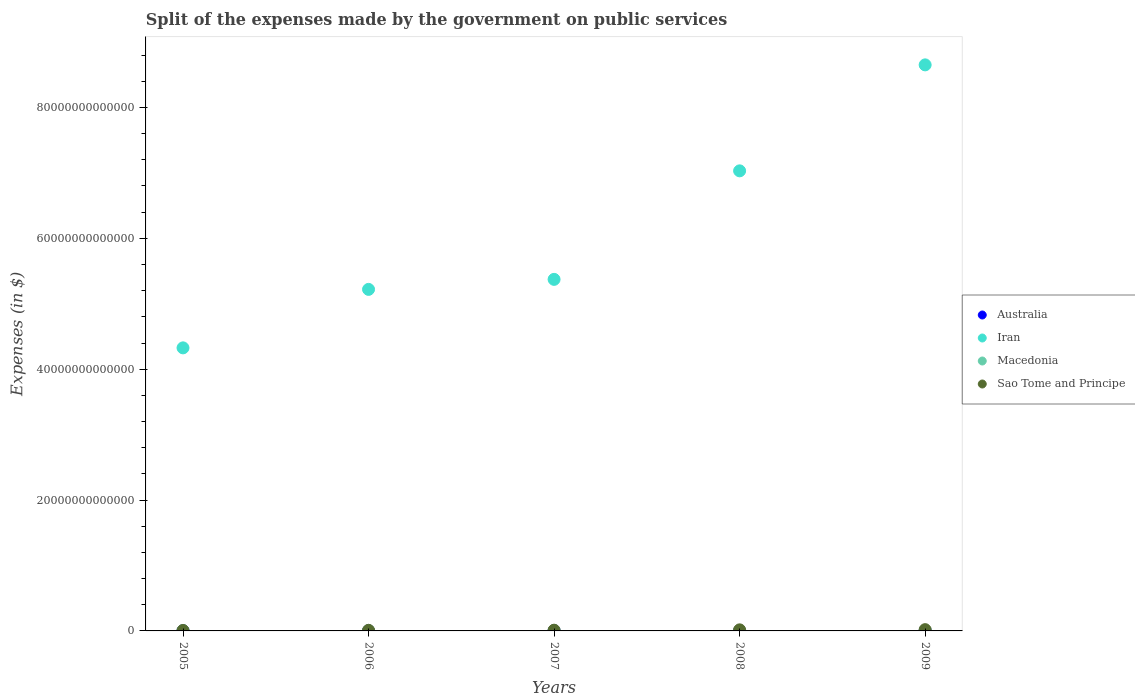What is the expenses made by the government on public services in Macedonia in 2008?
Your answer should be compact. 1.87e+1. Across all years, what is the maximum expenses made by the government on public services in Sao Tome and Principe?
Ensure brevity in your answer.  1.95e+11. Across all years, what is the minimum expenses made by the government on public services in Iran?
Keep it short and to the point. 4.33e+13. What is the total expenses made by the government on public services in Iran in the graph?
Provide a short and direct response. 3.06e+14. What is the difference between the expenses made by the government on public services in Australia in 2007 and that in 2008?
Your answer should be compact. -1.55e+09. What is the difference between the expenses made by the government on public services in Macedonia in 2006 and the expenses made by the government on public services in Australia in 2009?
Your answer should be very brief. -6.54e+09. What is the average expenses made by the government on public services in Sao Tome and Principe per year?
Your answer should be very brief. 1.26e+11. In the year 2006, what is the difference between the expenses made by the government on public services in Australia and expenses made by the government on public services in Sao Tome and Principe?
Ensure brevity in your answer.  -6.47e+1. In how many years, is the expenses made by the government on public services in Macedonia greater than 16000000000000 $?
Provide a short and direct response. 0. What is the ratio of the expenses made by the government on public services in Iran in 2007 to that in 2008?
Keep it short and to the point. 0.76. What is the difference between the highest and the second highest expenses made by the government on public services in Australia?
Ensure brevity in your answer.  2.16e+09. What is the difference between the highest and the lowest expenses made by the government on public services in Iran?
Your answer should be very brief. 4.32e+13. In how many years, is the expenses made by the government on public services in Macedonia greater than the average expenses made by the government on public services in Macedonia taken over all years?
Your response must be concise. 3. Does the expenses made by the government on public services in Macedonia monotonically increase over the years?
Your answer should be compact. No. Is the expenses made by the government on public services in Macedonia strictly greater than the expenses made by the government on public services in Australia over the years?
Make the answer very short. No. How many dotlines are there?
Make the answer very short. 4. What is the difference between two consecutive major ticks on the Y-axis?
Provide a short and direct response. 2.00e+13. Are the values on the major ticks of Y-axis written in scientific E-notation?
Keep it short and to the point. No. Does the graph contain any zero values?
Your answer should be compact. No. Where does the legend appear in the graph?
Make the answer very short. Center right. What is the title of the graph?
Your answer should be very brief. Split of the expenses made by the government on public services. What is the label or title of the Y-axis?
Offer a terse response. Expenses (in $). What is the Expenses (in $) in Australia in 2005?
Provide a succinct answer. 2.42e+1. What is the Expenses (in $) in Iran in 2005?
Offer a terse response. 4.33e+13. What is the Expenses (in $) in Macedonia in 2005?
Provide a short and direct response. 2.57e+1. What is the Expenses (in $) in Sao Tome and Principe in 2005?
Keep it short and to the point. 6.62e+1. What is the Expenses (in $) in Australia in 2006?
Your answer should be compact. 2.60e+1. What is the Expenses (in $) in Iran in 2006?
Ensure brevity in your answer.  5.22e+13. What is the Expenses (in $) in Macedonia in 2006?
Keep it short and to the point. 2.65e+1. What is the Expenses (in $) in Sao Tome and Principe in 2006?
Ensure brevity in your answer.  9.07e+1. What is the Expenses (in $) of Australia in 2007?
Give a very brief answer. 2.94e+1. What is the Expenses (in $) in Iran in 2007?
Provide a short and direct response. 5.37e+13. What is the Expenses (in $) of Macedonia in 2007?
Your response must be concise. 2.84e+1. What is the Expenses (in $) of Sao Tome and Principe in 2007?
Make the answer very short. 1.12e+11. What is the Expenses (in $) of Australia in 2008?
Keep it short and to the point. 3.09e+1. What is the Expenses (in $) of Iran in 2008?
Offer a very short reply. 7.03e+13. What is the Expenses (in $) in Macedonia in 2008?
Provide a short and direct response. 1.87e+1. What is the Expenses (in $) in Sao Tome and Principe in 2008?
Your answer should be compact. 1.64e+11. What is the Expenses (in $) of Australia in 2009?
Make the answer very short. 3.31e+1. What is the Expenses (in $) in Iran in 2009?
Offer a terse response. 8.65e+13. What is the Expenses (in $) in Macedonia in 2009?
Your answer should be compact. 1.62e+1. What is the Expenses (in $) of Sao Tome and Principe in 2009?
Provide a short and direct response. 1.95e+11. Across all years, what is the maximum Expenses (in $) in Australia?
Your response must be concise. 3.31e+1. Across all years, what is the maximum Expenses (in $) in Iran?
Your response must be concise. 8.65e+13. Across all years, what is the maximum Expenses (in $) in Macedonia?
Provide a succinct answer. 2.84e+1. Across all years, what is the maximum Expenses (in $) of Sao Tome and Principe?
Give a very brief answer. 1.95e+11. Across all years, what is the minimum Expenses (in $) of Australia?
Offer a very short reply. 2.42e+1. Across all years, what is the minimum Expenses (in $) in Iran?
Ensure brevity in your answer.  4.33e+13. Across all years, what is the minimum Expenses (in $) in Macedonia?
Give a very brief answer. 1.62e+1. Across all years, what is the minimum Expenses (in $) in Sao Tome and Principe?
Ensure brevity in your answer.  6.62e+1. What is the total Expenses (in $) in Australia in the graph?
Your answer should be very brief. 1.44e+11. What is the total Expenses (in $) of Iran in the graph?
Your answer should be very brief. 3.06e+14. What is the total Expenses (in $) in Macedonia in the graph?
Your response must be concise. 1.16e+11. What is the total Expenses (in $) in Sao Tome and Principe in the graph?
Offer a very short reply. 6.28e+11. What is the difference between the Expenses (in $) of Australia in 2005 and that in 2006?
Ensure brevity in your answer.  -1.84e+09. What is the difference between the Expenses (in $) in Iran in 2005 and that in 2006?
Give a very brief answer. -8.94e+12. What is the difference between the Expenses (in $) of Macedonia in 2005 and that in 2006?
Make the answer very short. -8.61e+08. What is the difference between the Expenses (in $) of Sao Tome and Principe in 2005 and that in 2006?
Your answer should be compact. -2.45e+1. What is the difference between the Expenses (in $) in Australia in 2005 and that in 2007?
Provide a short and direct response. -5.17e+09. What is the difference between the Expenses (in $) in Iran in 2005 and that in 2007?
Offer a terse response. -1.05e+13. What is the difference between the Expenses (in $) of Macedonia in 2005 and that in 2007?
Provide a short and direct response. -2.77e+09. What is the difference between the Expenses (in $) of Sao Tome and Principe in 2005 and that in 2007?
Make the answer very short. -4.53e+1. What is the difference between the Expenses (in $) of Australia in 2005 and that in 2008?
Your response must be concise. -6.72e+09. What is the difference between the Expenses (in $) in Iran in 2005 and that in 2008?
Your response must be concise. -2.71e+13. What is the difference between the Expenses (in $) of Macedonia in 2005 and that in 2008?
Provide a short and direct response. 6.93e+09. What is the difference between the Expenses (in $) in Sao Tome and Principe in 2005 and that in 2008?
Give a very brief answer. -9.81e+1. What is the difference between the Expenses (in $) in Australia in 2005 and that in 2009?
Your answer should be very brief. -8.88e+09. What is the difference between the Expenses (in $) of Iran in 2005 and that in 2009?
Your answer should be compact. -4.32e+13. What is the difference between the Expenses (in $) of Macedonia in 2005 and that in 2009?
Make the answer very short. 9.46e+09. What is the difference between the Expenses (in $) in Sao Tome and Principe in 2005 and that in 2009?
Offer a very short reply. -1.29e+11. What is the difference between the Expenses (in $) of Australia in 2006 and that in 2007?
Your answer should be compact. -3.32e+09. What is the difference between the Expenses (in $) in Iran in 2006 and that in 2007?
Keep it short and to the point. -1.53e+12. What is the difference between the Expenses (in $) of Macedonia in 2006 and that in 2007?
Give a very brief answer. -1.91e+09. What is the difference between the Expenses (in $) of Sao Tome and Principe in 2006 and that in 2007?
Your response must be concise. -2.08e+1. What is the difference between the Expenses (in $) in Australia in 2006 and that in 2008?
Make the answer very short. -4.88e+09. What is the difference between the Expenses (in $) of Iran in 2006 and that in 2008?
Give a very brief answer. -1.81e+13. What is the difference between the Expenses (in $) in Macedonia in 2006 and that in 2008?
Your response must be concise. 7.79e+09. What is the difference between the Expenses (in $) of Sao Tome and Principe in 2006 and that in 2008?
Offer a very short reply. -7.36e+1. What is the difference between the Expenses (in $) of Australia in 2006 and that in 2009?
Keep it short and to the point. -7.03e+09. What is the difference between the Expenses (in $) in Iran in 2006 and that in 2009?
Make the answer very short. -3.43e+13. What is the difference between the Expenses (in $) in Macedonia in 2006 and that in 2009?
Provide a succinct answer. 1.03e+1. What is the difference between the Expenses (in $) of Sao Tome and Principe in 2006 and that in 2009?
Provide a succinct answer. -1.04e+11. What is the difference between the Expenses (in $) of Australia in 2007 and that in 2008?
Offer a very short reply. -1.55e+09. What is the difference between the Expenses (in $) of Iran in 2007 and that in 2008?
Provide a short and direct response. -1.66e+13. What is the difference between the Expenses (in $) in Macedonia in 2007 and that in 2008?
Your answer should be compact. 9.70e+09. What is the difference between the Expenses (in $) of Sao Tome and Principe in 2007 and that in 2008?
Your response must be concise. -5.27e+1. What is the difference between the Expenses (in $) in Australia in 2007 and that in 2009?
Keep it short and to the point. -3.71e+09. What is the difference between the Expenses (in $) of Iran in 2007 and that in 2009?
Provide a short and direct response. -3.28e+13. What is the difference between the Expenses (in $) in Macedonia in 2007 and that in 2009?
Your response must be concise. 1.22e+1. What is the difference between the Expenses (in $) of Sao Tome and Principe in 2007 and that in 2009?
Offer a very short reply. -8.33e+1. What is the difference between the Expenses (in $) of Australia in 2008 and that in 2009?
Make the answer very short. -2.16e+09. What is the difference between the Expenses (in $) of Iran in 2008 and that in 2009?
Offer a very short reply. -1.62e+13. What is the difference between the Expenses (in $) in Macedonia in 2008 and that in 2009?
Your response must be concise. 2.52e+09. What is the difference between the Expenses (in $) in Sao Tome and Principe in 2008 and that in 2009?
Provide a succinct answer. -3.06e+1. What is the difference between the Expenses (in $) in Australia in 2005 and the Expenses (in $) in Iran in 2006?
Keep it short and to the point. -5.22e+13. What is the difference between the Expenses (in $) in Australia in 2005 and the Expenses (in $) in Macedonia in 2006?
Your answer should be compact. -2.33e+09. What is the difference between the Expenses (in $) of Australia in 2005 and the Expenses (in $) of Sao Tome and Principe in 2006?
Ensure brevity in your answer.  -6.65e+1. What is the difference between the Expenses (in $) of Iran in 2005 and the Expenses (in $) of Macedonia in 2006?
Provide a succinct answer. 4.32e+13. What is the difference between the Expenses (in $) of Iran in 2005 and the Expenses (in $) of Sao Tome and Principe in 2006?
Ensure brevity in your answer.  4.32e+13. What is the difference between the Expenses (in $) of Macedonia in 2005 and the Expenses (in $) of Sao Tome and Principe in 2006?
Provide a succinct answer. -6.50e+1. What is the difference between the Expenses (in $) in Australia in 2005 and the Expenses (in $) in Iran in 2007?
Keep it short and to the point. -5.37e+13. What is the difference between the Expenses (in $) in Australia in 2005 and the Expenses (in $) in Macedonia in 2007?
Your response must be concise. -4.24e+09. What is the difference between the Expenses (in $) in Australia in 2005 and the Expenses (in $) in Sao Tome and Principe in 2007?
Ensure brevity in your answer.  -8.73e+1. What is the difference between the Expenses (in $) in Iran in 2005 and the Expenses (in $) in Macedonia in 2007?
Ensure brevity in your answer.  4.32e+13. What is the difference between the Expenses (in $) in Iran in 2005 and the Expenses (in $) in Sao Tome and Principe in 2007?
Provide a succinct answer. 4.31e+13. What is the difference between the Expenses (in $) in Macedonia in 2005 and the Expenses (in $) in Sao Tome and Principe in 2007?
Your answer should be very brief. -8.59e+1. What is the difference between the Expenses (in $) of Australia in 2005 and the Expenses (in $) of Iran in 2008?
Give a very brief answer. -7.03e+13. What is the difference between the Expenses (in $) of Australia in 2005 and the Expenses (in $) of Macedonia in 2008?
Keep it short and to the point. 5.46e+09. What is the difference between the Expenses (in $) in Australia in 2005 and the Expenses (in $) in Sao Tome and Principe in 2008?
Provide a succinct answer. -1.40e+11. What is the difference between the Expenses (in $) in Iran in 2005 and the Expenses (in $) in Macedonia in 2008?
Make the answer very short. 4.32e+13. What is the difference between the Expenses (in $) in Iran in 2005 and the Expenses (in $) in Sao Tome and Principe in 2008?
Give a very brief answer. 4.31e+13. What is the difference between the Expenses (in $) of Macedonia in 2005 and the Expenses (in $) of Sao Tome and Principe in 2008?
Your answer should be compact. -1.39e+11. What is the difference between the Expenses (in $) of Australia in 2005 and the Expenses (in $) of Iran in 2009?
Give a very brief answer. -8.65e+13. What is the difference between the Expenses (in $) of Australia in 2005 and the Expenses (in $) of Macedonia in 2009?
Your answer should be very brief. 7.98e+09. What is the difference between the Expenses (in $) of Australia in 2005 and the Expenses (in $) of Sao Tome and Principe in 2009?
Your answer should be compact. -1.71e+11. What is the difference between the Expenses (in $) in Iran in 2005 and the Expenses (in $) in Macedonia in 2009?
Give a very brief answer. 4.32e+13. What is the difference between the Expenses (in $) in Iran in 2005 and the Expenses (in $) in Sao Tome and Principe in 2009?
Your response must be concise. 4.31e+13. What is the difference between the Expenses (in $) in Macedonia in 2005 and the Expenses (in $) in Sao Tome and Principe in 2009?
Your answer should be very brief. -1.69e+11. What is the difference between the Expenses (in $) in Australia in 2006 and the Expenses (in $) in Iran in 2007?
Offer a terse response. -5.37e+13. What is the difference between the Expenses (in $) in Australia in 2006 and the Expenses (in $) in Macedonia in 2007?
Your response must be concise. -2.40e+09. What is the difference between the Expenses (in $) in Australia in 2006 and the Expenses (in $) in Sao Tome and Principe in 2007?
Make the answer very short. -8.55e+1. What is the difference between the Expenses (in $) in Iran in 2006 and the Expenses (in $) in Macedonia in 2007?
Provide a short and direct response. 5.22e+13. What is the difference between the Expenses (in $) in Iran in 2006 and the Expenses (in $) in Sao Tome and Principe in 2007?
Offer a terse response. 5.21e+13. What is the difference between the Expenses (in $) of Macedonia in 2006 and the Expenses (in $) of Sao Tome and Principe in 2007?
Your answer should be very brief. -8.50e+1. What is the difference between the Expenses (in $) of Australia in 2006 and the Expenses (in $) of Iran in 2008?
Keep it short and to the point. -7.03e+13. What is the difference between the Expenses (in $) in Australia in 2006 and the Expenses (in $) in Macedonia in 2008?
Offer a terse response. 7.30e+09. What is the difference between the Expenses (in $) in Australia in 2006 and the Expenses (in $) in Sao Tome and Principe in 2008?
Offer a terse response. -1.38e+11. What is the difference between the Expenses (in $) in Iran in 2006 and the Expenses (in $) in Macedonia in 2008?
Offer a terse response. 5.22e+13. What is the difference between the Expenses (in $) in Iran in 2006 and the Expenses (in $) in Sao Tome and Principe in 2008?
Your response must be concise. 5.20e+13. What is the difference between the Expenses (in $) of Macedonia in 2006 and the Expenses (in $) of Sao Tome and Principe in 2008?
Your answer should be very brief. -1.38e+11. What is the difference between the Expenses (in $) of Australia in 2006 and the Expenses (in $) of Iran in 2009?
Make the answer very short. -8.65e+13. What is the difference between the Expenses (in $) of Australia in 2006 and the Expenses (in $) of Macedonia in 2009?
Make the answer very short. 9.83e+09. What is the difference between the Expenses (in $) in Australia in 2006 and the Expenses (in $) in Sao Tome and Principe in 2009?
Make the answer very short. -1.69e+11. What is the difference between the Expenses (in $) of Iran in 2006 and the Expenses (in $) of Macedonia in 2009?
Offer a terse response. 5.22e+13. What is the difference between the Expenses (in $) in Iran in 2006 and the Expenses (in $) in Sao Tome and Principe in 2009?
Offer a very short reply. 5.20e+13. What is the difference between the Expenses (in $) in Macedonia in 2006 and the Expenses (in $) in Sao Tome and Principe in 2009?
Offer a terse response. -1.68e+11. What is the difference between the Expenses (in $) in Australia in 2007 and the Expenses (in $) in Iran in 2008?
Offer a terse response. -7.03e+13. What is the difference between the Expenses (in $) of Australia in 2007 and the Expenses (in $) of Macedonia in 2008?
Ensure brevity in your answer.  1.06e+1. What is the difference between the Expenses (in $) in Australia in 2007 and the Expenses (in $) in Sao Tome and Principe in 2008?
Your response must be concise. -1.35e+11. What is the difference between the Expenses (in $) in Iran in 2007 and the Expenses (in $) in Macedonia in 2008?
Offer a terse response. 5.37e+13. What is the difference between the Expenses (in $) of Iran in 2007 and the Expenses (in $) of Sao Tome and Principe in 2008?
Provide a succinct answer. 5.36e+13. What is the difference between the Expenses (in $) of Macedonia in 2007 and the Expenses (in $) of Sao Tome and Principe in 2008?
Ensure brevity in your answer.  -1.36e+11. What is the difference between the Expenses (in $) of Australia in 2007 and the Expenses (in $) of Iran in 2009?
Give a very brief answer. -8.65e+13. What is the difference between the Expenses (in $) of Australia in 2007 and the Expenses (in $) of Macedonia in 2009?
Make the answer very short. 1.32e+1. What is the difference between the Expenses (in $) in Australia in 2007 and the Expenses (in $) in Sao Tome and Principe in 2009?
Your answer should be compact. -1.65e+11. What is the difference between the Expenses (in $) in Iran in 2007 and the Expenses (in $) in Macedonia in 2009?
Offer a very short reply. 5.37e+13. What is the difference between the Expenses (in $) of Iran in 2007 and the Expenses (in $) of Sao Tome and Principe in 2009?
Give a very brief answer. 5.35e+13. What is the difference between the Expenses (in $) of Macedonia in 2007 and the Expenses (in $) of Sao Tome and Principe in 2009?
Provide a succinct answer. -1.66e+11. What is the difference between the Expenses (in $) of Australia in 2008 and the Expenses (in $) of Iran in 2009?
Provide a succinct answer. -8.65e+13. What is the difference between the Expenses (in $) in Australia in 2008 and the Expenses (in $) in Macedonia in 2009?
Ensure brevity in your answer.  1.47e+1. What is the difference between the Expenses (in $) in Australia in 2008 and the Expenses (in $) in Sao Tome and Principe in 2009?
Ensure brevity in your answer.  -1.64e+11. What is the difference between the Expenses (in $) in Iran in 2008 and the Expenses (in $) in Macedonia in 2009?
Your response must be concise. 7.03e+13. What is the difference between the Expenses (in $) of Iran in 2008 and the Expenses (in $) of Sao Tome and Principe in 2009?
Your response must be concise. 7.01e+13. What is the difference between the Expenses (in $) of Macedonia in 2008 and the Expenses (in $) of Sao Tome and Principe in 2009?
Keep it short and to the point. -1.76e+11. What is the average Expenses (in $) of Australia per year?
Offer a terse response. 2.87e+1. What is the average Expenses (in $) in Iran per year?
Ensure brevity in your answer.  6.12e+13. What is the average Expenses (in $) of Macedonia per year?
Your response must be concise. 2.31e+1. What is the average Expenses (in $) in Sao Tome and Principe per year?
Provide a short and direct response. 1.26e+11. In the year 2005, what is the difference between the Expenses (in $) of Australia and Expenses (in $) of Iran?
Provide a succinct answer. -4.32e+13. In the year 2005, what is the difference between the Expenses (in $) of Australia and Expenses (in $) of Macedonia?
Your response must be concise. -1.47e+09. In the year 2005, what is the difference between the Expenses (in $) in Australia and Expenses (in $) in Sao Tome and Principe?
Give a very brief answer. -4.20e+1. In the year 2005, what is the difference between the Expenses (in $) in Iran and Expenses (in $) in Macedonia?
Give a very brief answer. 4.32e+13. In the year 2005, what is the difference between the Expenses (in $) in Iran and Expenses (in $) in Sao Tome and Principe?
Offer a terse response. 4.32e+13. In the year 2005, what is the difference between the Expenses (in $) of Macedonia and Expenses (in $) of Sao Tome and Principe?
Offer a very short reply. -4.05e+1. In the year 2006, what is the difference between the Expenses (in $) in Australia and Expenses (in $) in Iran?
Offer a very short reply. -5.22e+13. In the year 2006, what is the difference between the Expenses (in $) in Australia and Expenses (in $) in Macedonia?
Your response must be concise. -4.90e+08. In the year 2006, what is the difference between the Expenses (in $) in Australia and Expenses (in $) in Sao Tome and Principe?
Your response must be concise. -6.47e+1. In the year 2006, what is the difference between the Expenses (in $) in Iran and Expenses (in $) in Macedonia?
Your response must be concise. 5.22e+13. In the year 2006, what is the difference between the Expenses (in $) of Iran and Expenses (in $) of Sao Tome and Principe?
Provide a short and direct response. 5.21e+13. In the year 2006, what is the difference between the Expenses (in $) in Macedonia and Expenses (in $) in Sao Tome and Principe?
Make the answer very short. -6.42e+1. In the year 2007, what is the difference between the Expenses (in $) of Australia and Expenses (in $) of Iran?
Give a very brief answer. -5.37e+13. In the year 2007, what is the difference between the Expenses (in $) of Australia and Expenses (in $) of Macedonia?
Offer a terse response. 9.25e+08. In the year 2007, what is the difference between the Expenses (in $) of Australia and Expenses (in $) of Sao Tome and Principe?
Keep it short and to the point. -8.22e+1. In the year 2007, what is the difference between the Expenses (in $) in Iran and Expenses (in $) in Macedonia?
Your answer should be very brief. 5.37e+13. In the year 2007, what is the difference between the Expenses (in $) in Iran and Expenses (in $) in Sao Tome and Principe?
Provide a succinct answer. 5.36e+13. In the year 2007, what is the difference between the Expenses (in $) of Macedonia and Expenses (in $) of Sao Tome and Principe?
Make the answer very short. -8.31e+1. In the year 2008, what is the difference between the Expenses (in $) of Australia and Expenses (in $) of Iran?
Provide a short and direct response. -7.03e+13. In the year 2008, what is the difference between the Expenses (in $) of Australia and Expenses (in $) of Macedonia?
Provide a short and direct response. 1.22e+1. In the year 2008, what is the difference between the Expenses (in $) in Australia and Expenses (in $) in Sao Tome and Principe?
Give a very brief answer. -1.33e+11. In the year 2008, what is the difference between the Expenses (in $) in Iran and Expenses (in $) in Macedonia?
Offer a very short reply. 7.03e+13. In the year 2008, what is the difference between the Expenses (in $) in Iran and Expenses (in $) in Sao Tome and Principe?
Keep it short and to the point. 7.01e+13. In the year 2008, what is the difference between the Expenses (in $) of Macedonia and Expenses (in $) of Sao Tome and Principe?
Your answer should be compact. -1.46e+11. In the year 2009, what is the difference between the Expenses (in $) in Australia and Expenses (in $) in Iran?
Your answer should be very brief. -8.65e+13. In the year 2009, what is the difference between the Expenses (in $) in Australia and Expenses (in $) in Macedonia?
Offer a terse response. 1.69e+1. In the year 2009, what is the difference between the Expenses (in $) in Australia and Expenses (in $) in Sao Tome and Principe?
Offer a very short reply. -1.62e+11. In the year 2009, what is the difference between the Expenses (in $) in Iran and Expenses (in $) in Macedonia?
Your answer should be very brief. 8.65e+13. In the year 2009, what is the difference between the Expenses (in $) in Iran and Expenses (in $) in Sao Tome and Principe?
Provide a short and direct response. 8.63e+13. In the year 2009, what is the difference between the Expenses (in $) of Macedonia and Expenses (in $) of Sao Tome and Principe?
Your answer should be very brief. -1.79e+11. What is the ratio of the Expenses (in $) in Australia in 2005 to that in 2006?
Offer a very short reply. 0.93. What is the ratio of the Expenses (in $) in Iran in 2005 to that in 2006?
Ensure brevity in your answer.  0.83. What is the ratio of the Expenses (in $) in Macedonia in 2005 to that in 2006?
Give a very brief answer. 0.97. What is the ratio of the Expenses (in $) in Sao Tome and Principe in 2005 to that in 2006?
Offer a very short reply. 0.73. What is the ratio of the Expenses (in $) in Australia in 2005 to that in 2007?
Offer a very short reply. 0.82. What is the ratio of the Expenses (in $) in Iran in 2005 to that in 2007?
Give a very brief answer. 0.81. What is the ratio of the Expenses (in $) of Macedonia in 2005 to that in 2007?
Offer a very short reply. 0.9. What is the ratio of the Expenses (in $) of Sao Tome and Principe in 2005 to that in 2007?
Offer a very short reply. 0.59. What is the ratio of the Expenses (in $) of Australia in 2005 to that in 2008?
Your answer should be very brief. 0.78. What is the ratio of the Expenses (in $) in Iran in 2005 to that in 2008?
Keep it short and to the point. 0.62. What is the ratio of the Expenses (in $) of Macedonia in 2005 to that in 2008?
Offer a terse response. 1.37. What is the ratio of the Expenses (in $) in Sao Tome and Principe in 2005 to that in 2008?
Your answer should be compact. 0.4. What is the ratio of the Expenses (in $) in Australia in 2005 to that in 2009?
Your response must be concise. 0.73. What is the ratio of the Expenses (in $) of Iran in 2005 to that in 2009?
Ensure brevity in your answer.  0.5. What is the ratio of the Expenses (in $) of Macedonia in 2005 to that in 2009?
Give a very brief answer. 1.58. What is the ratio of the Expenses (in $) in Sao Tome and Principe in 2005 to that in 2009?
Your response must be concise. 0.34. What is the ratio of the Expenses (in $) in Australia in 2006 to that in 2007?
Your answer should be very brief. 0.89. What is the ratio of the Expenses (in $) in Iran in 2006 to that in 2007?
Your response must be concise. 0.97. What is the ratio of the Expenses (in $) of Macedonia in 2006 to that in 2007?
Your answer should be very brief. 0.93. What is the ratio of the Expenses (in $) in Sao Tome and Principe in 2006 to that in 2007?
Make the answer very short. 0.81. What is the ratio of the Expenses (in $) of Australia in 2006 to that in 2008?
Your answer should be compact. 0.84. What is the ratio of the Expenses (in $) in Iran in 2006 to that in 2008?
Your response must be concise. 0.74. What is the ratio of the Expenses (in $) in Macedonia in 2006 to that in 2008?
Your answer should be compact. 1.42. What is the ratio of the Expenses (in $) in Sao Tome and Principe in 2006 to that in 2008?
Provide a succinct answer. 0.55. What is the ratio of the Expenses (in $) in Australia in 2006 to that in 2009?
Ensure brevity in your answer.  0.79. What is the ratio of the Expenses (in $) of Iran in 2006 to that in 2009?
Your response must be concise. 0.6. What is the ratio of the Expenses (in $) in Macedonia in 2006 to that in 2009?
Your answer should be compact. 1.64. What is the ratio of the Expenses (in $) in Sao Tome and Principe in 2006 to that in 2009?
Ensure brevity in your answer.  0.47. What is the ratio of the Expenses (in $) of Australia in 2007 to that in 2008?
Your answer should be very brief. 0.95. What is the ratio of the Expenses (in $) in Iran in 2007 to that in 2008?
Provide a succinct answer. 0.76. What is the ratio of the Expenses (in $) in Macedonia in 2007 to that in 2008?
Your response must be concise. 1.52. What is the ratio of the Expenses (in $) in Sao Tome and Principe in 2007 to that in 2008?
Your answer should be compact. 0.68. What is the ratio of the Expenses (in $) of Australia in 2007 to that in 2009?
Your answer should be very brief. 0.89. What is the ratio of the Expenses (in $) of Iran in 2007 to that in 2009?
Give a very brief answer. 0.62. What is the ratio of the Expenses (in $) of Macedonia in 2007 to that in 2009?
Provide a short and direct response. 1.75. What is the ratio of the Expenses (in $) of Sao Tome and Principe in 2007 to that in 2009?
Your answer should be compact. 0.57. What is the ratio of the Expenses (in $) in Australia in 2008 to that in 2009?
Your answer should be compact. 0.93. What is the ratio of the Expenses (in $) of Iran in 2008 to that in 2009?
Your answer should be compact. 0.81. What is the ratio of the Expenses (in $) in Macedonia in 2008 to that in 2009?
Provide a short and direct response. 1.16. What is the ratio of the Expenses (in $) in Sao Tome and Principe in 2008 to that in 2009?
Ensure brevity in your answer.  0.84. What is the difference between the highest and the second highest Expenses (in $) of Australia?
Your answer should be very brief. 2.16e+09. What is the difference between the highest and the second highest Expenses (in $) of Iran?
Offer a terse response. 1.62e+13. What is the difference between the highest and the second highest Expenses (in $) of Macedonia?
Ensure brevity in your answer.  1.91e+09. What is the difference between the highest and the second highest Expenses (in $) of Sao Tome and Principe?
Your response must be concise. 3.06e+1. What is the difference between the highest and the lowest Expenses (in $) of Australia?
Give a very brief answer. 8.88e+09. What is the difference between the highest and the lowest Expenses (in $) in Iran?
Your response must be concise. 4.32e+13. What is the difference between the highest and the lowest Expenses (in $) in Macedonia?
Keep it short and to the point. 1.22e+1. What is the difference between the highest and the lowest Expenses (in $) of Sao Tome and Principe?
Make the answer very short. 1.29e+11. 